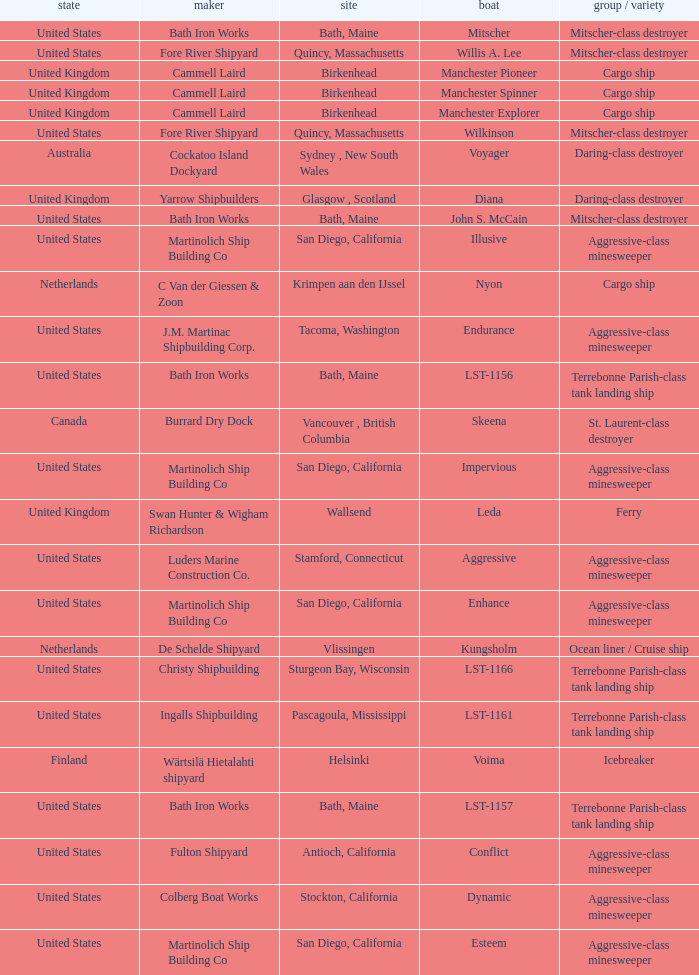Parse the table in full. {'header': ['state', 'maker', 'site', 'boat', 'group / variety'], 'rows': [['United States', 'Bath Iron Works', 'Bath, Maine', 'Mitscher', 'Mitscher-class destroyer'], ['United States', 'Fore River Shipyard', 'Quincy, Massachusetts', 'Willis A. Lee', 'Mitscher-class destroyer'], ['United Kingdom', 'Cammell Laird', 'Birkenhead', 'Manchester Pioneer', 'Cargo ship'], ['United Kingdom', 'Cammell Laird', 'Birkenhead', 'Manchester Spinner', 'Cargo ship'], ['United Kingdom', 'Cammell Laird', 'Birkenhead', 'Manchester Explorer', 'Cargo ship'], ['United States', 'Fore River Shipyard', 'Quincy, Massachusetts', 'Wilkinson', 'Mitscher-class destroyer'], ['Australia', 'Cockatoo Island Dockyard', 'Sydney , New South Wales', 'Voyager', 'Daring-class destroyer'], ['United Kingdom', 'Yarrow Shipbuilders', 'Glasgow , Scotland', 'Diana', 'Daring-class destroyer'], ['United States', 'Bath Iron Works', 'Bath, Maine', 'John S. McCain', 'Mitscher-class destroyer'], ['United States', 'Martinolich Ship Building Co', 'San Diego, California', 'Illusive', 'Aggressive-class minesweeper'], ['Netherlands', 'C Van der Giessen & Zoon', 'Krimpen aan den IJssel', 'Nyon', 'Cargo ship'], ['United States', 'J.M. Martinac Shipbuilding Corp.', 'Tacoma, Washington', 'Endurance', 'Aggressive-class minesweeper'], ['United States', 'Bath Iron Works', 'Bath, Maine', 'LST-1156', 'Terrebonne Parish-class tank landing ship'], ['Canada', 'Burrard Dry Dock', 'Vancouver , British Columbia', 'Skeena', 'St. Laurent-class destroyer'], ['United States', 'Martinolich Ship Building Co', 'San Diego, California', 'Impervious', 'Aggressive-class minesweeper'], ['United Kingdom', 'Swan Hunter & Wigham Richardson', 'Wallsend', 'Leda', 'Ferry'], ['United States', 'Luders Marine Construction Co.', 'Stamford, Connecticut', 'Aggressive', 'Aggressive-class minesweeper'], ['United States', 'Martinolich Ship Building Co', 'San Diego, California', 'Enhance', 'Aggressive-class minesweeper'], ['Netherlands', 'De Schelde Shipyard', 'Vlissingen', 'Kungsholm', 'Ocean liner / Cruise ship'], ['United States', 'Christy Shipbuilding', 'Sturgeon Bay, Wisconsin', 'LST-1166', 'Terrebonne Parish-class tank landing ship'], ['United States', 'Ingalls Shipbuilding', 'Pascagoula, Mississippi', 'LST-1161', 'Terrebonne Parish-class tank landing ship'], ['Finland', 'Wärtsilä Hietalahti shipyard', 'Helsinki', 'Voima', 'Icebreaker'], ['United States', 'Bath Iron Works', 'Bath, Maine', 'LST-1157', 'Terrebonne Parish-class tank landing ship'], ['United States', 'Fulton Shipyard', 'Antioch, California', 'Conflict', 'Aggressive-class minesweeper'], ['United States', 'Colberg Boat Works', 'Stockton, California', 'Dynamic', 'Aggressive-class minesweeper'], ['United States', 'Martinolich Ship Building Co', 'San Diego, California', 'Esteem', 'Aggressive-class minesweeper']]} What Ship was Built by Cammell Laird? Manchester Pioneer, Manchester Spinner, Manchester Explorer. 